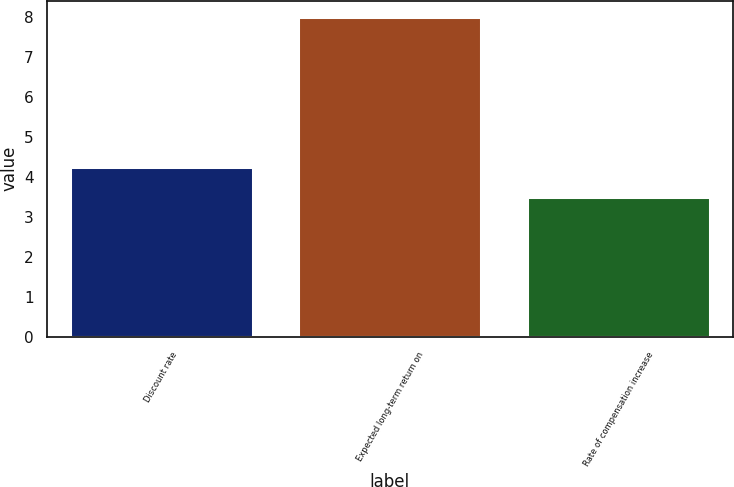Convert chart to OTSL. <chart><loc_0><loc_0><loc_500><loc_500><bar_chart><fcel>Discount rate<fcel>Expected long-term return on<fcel>Rate of compensation increase<nl><fcel>4.25<fcel>8<fcel>3.5<nl></chart> 